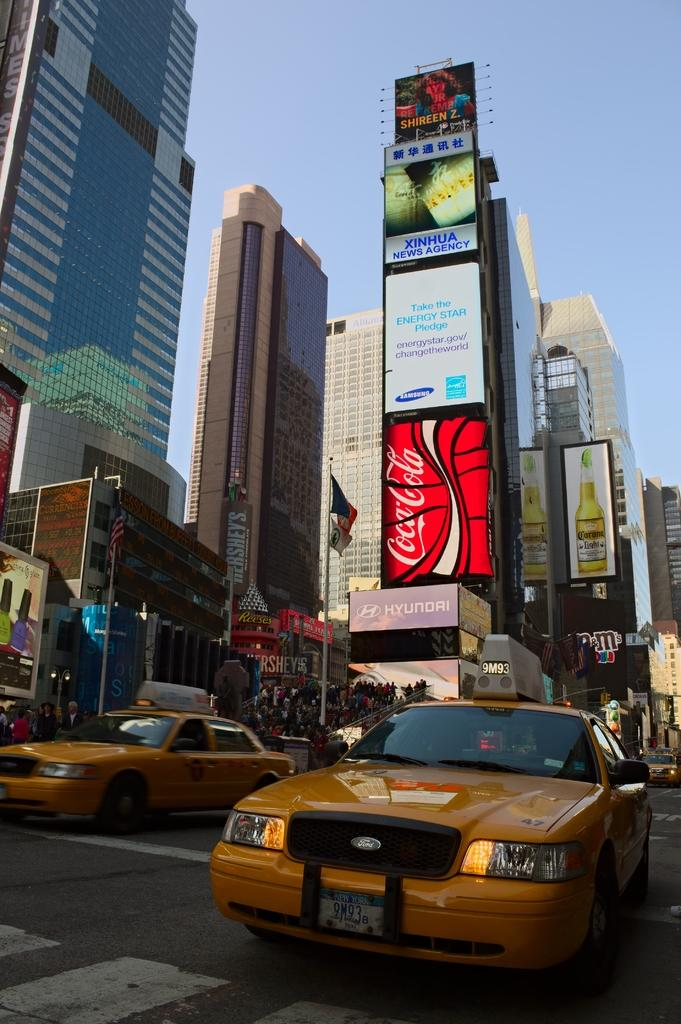<image>
Provide a brief description of the given image. A New York taxi is seen before buildings one of which has a Coca-Cola advert on it. 